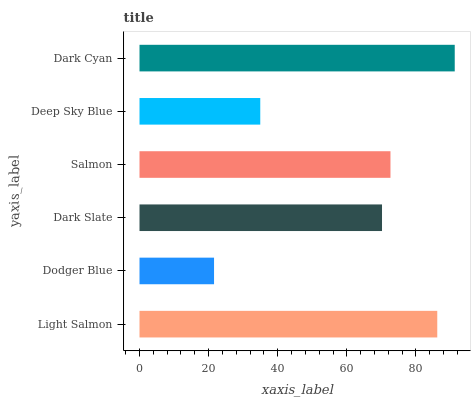Is Dodger Blue the minimum?
Answer yes or no. Yes. Is Dark Cyan the maximum?
Answer yes or no. Yes. Is Dark Slate the minimum?
Answer yes or no. No. Is Dark Slate the maximum?
Answer yes or no. No. Is Dark Slate greater than Dodger Blue?
Answer yes or no. Yes. Is Dodger Blue less than Dark Slate?
Answer yes or no. Yes. Is Dodger Blue greater than Dark Slate?
Answer yes or no. No. Is Dark Slate less than Dodger Blue?
Answer yes or no. No. Is Salmon the high median?
Answer yes or no. Yes. Is Dark Slate the low median?
Answer yes or no. Yes. Is Dark Slate the high median?
Answer yes or no. No. Is Light Salmon the low median?
Answer yes or no. No. 